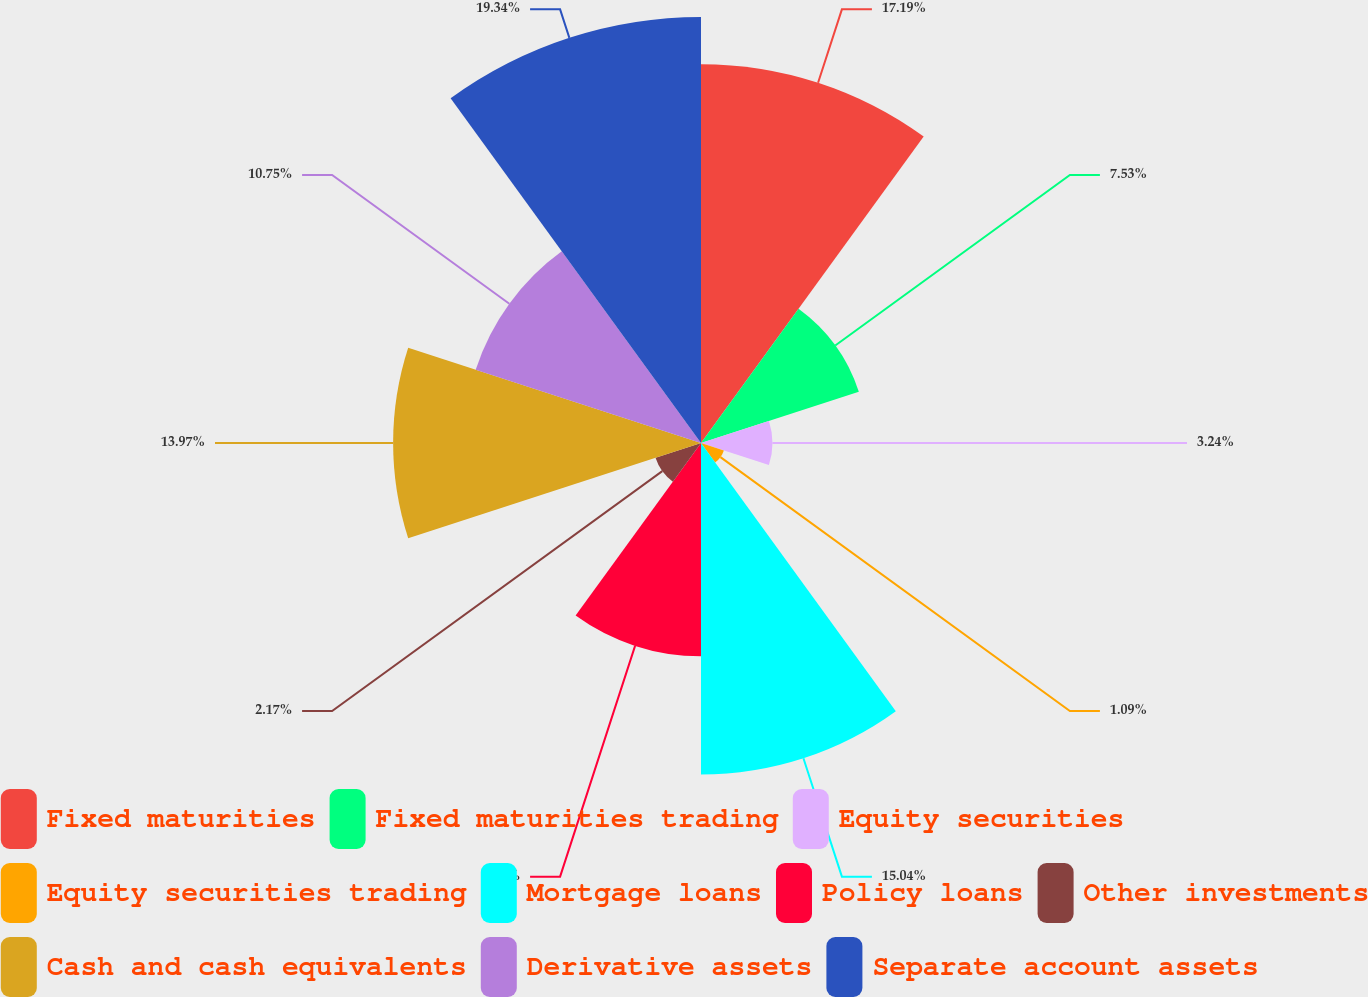Convert chart. <chart><loc_0><loc_0><loc_500><loc_500><pie_chart><fcel>Fixed maturities<fcel>Fixed maturities trading<fcel>Equity securities<fcel>Equity securities trading<fcel>Mortgage loans<fcel>Policy loans<fcel>Other investments<fcel>Cash and cash equivalents<fcel>Derivative assets<fcel>Separate account assets<nl><fcel>17.19%<fcel>7.53%<fcel>3.24%<fcel>1.09%<fcel>15.04%<fcel>9.68%<fcel>2.17%<fcel>13.97%<fcel>10.75%<fcel>19.33%<nl></chart> 